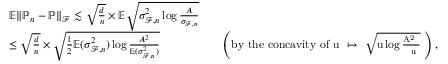<formula> <loc_0><loc_0><loc_500><loc_500>\begin{array} { r } { \begin{array} { r l r l } & { \mathbb { E } \| \mathbb { P } _ { n } - \mathbb { P } \| _ { \mathcal { F } } \lesssim \sqrt { \frac { d } { n } } \times \mathbb { E } \sqrt { \sigma _ { \mathcal { F } , n } ^ { 2 } \log { \frac { A } { \sigma _ { \mathcal { F } , n } } } } } \\ & { \leq \sqrt { \frac { d } { n } } \times \sqrt { { \frac { 1 } { 2 } } \mathbb { E } ( \sigma _ { \mathcal { F } , n } ^ { 2 } ) \log { \frac { A ^ { 2 } } { \mathbb { E } ( \sigma _ { \mathcal { F } , n } ^ { 2 } ) } } } } & & { \left ( b y t h e c o n c a v i t y o f u \mapsto \sqrt { u \log { \frac { A ^ { 2 } } { u } } } \right ) , } \end{array} } \end{array}</formula> 